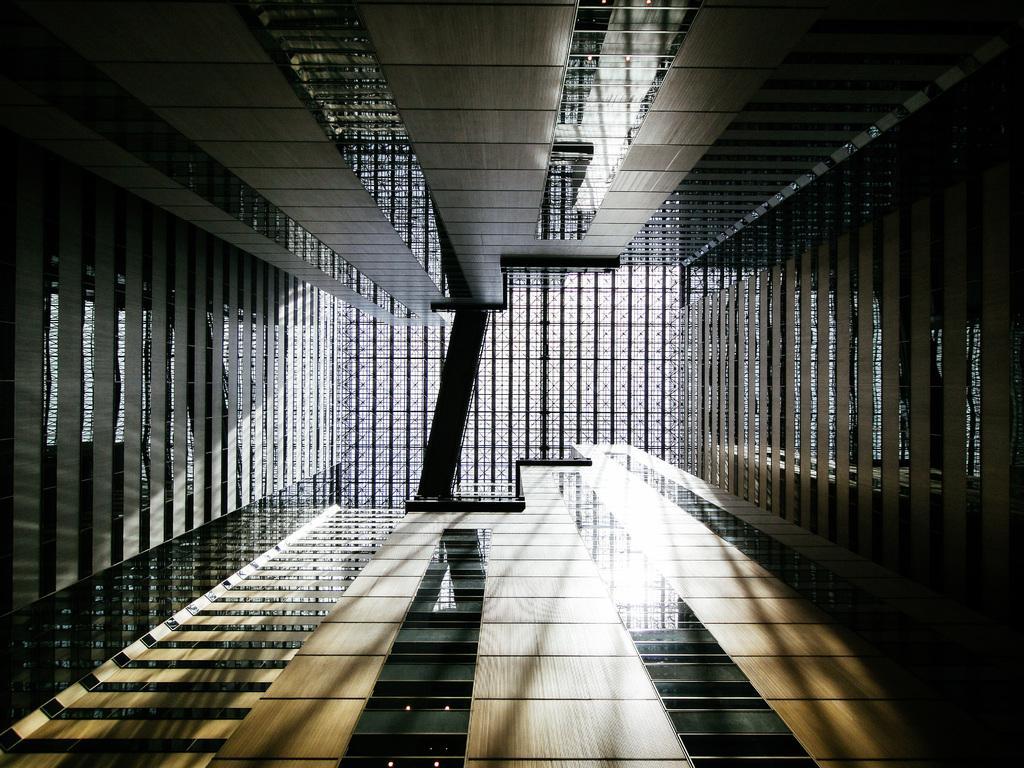Please provide a concise description of this image. In this image I can see the buildings which are in black and brown color. 